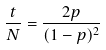<formula> <loc_0><loc_0><loc_500><loc_500>\frac { t } { N } = \frac { 2 p } { ( 1 - p ) ^ { 2 } }</formula> 